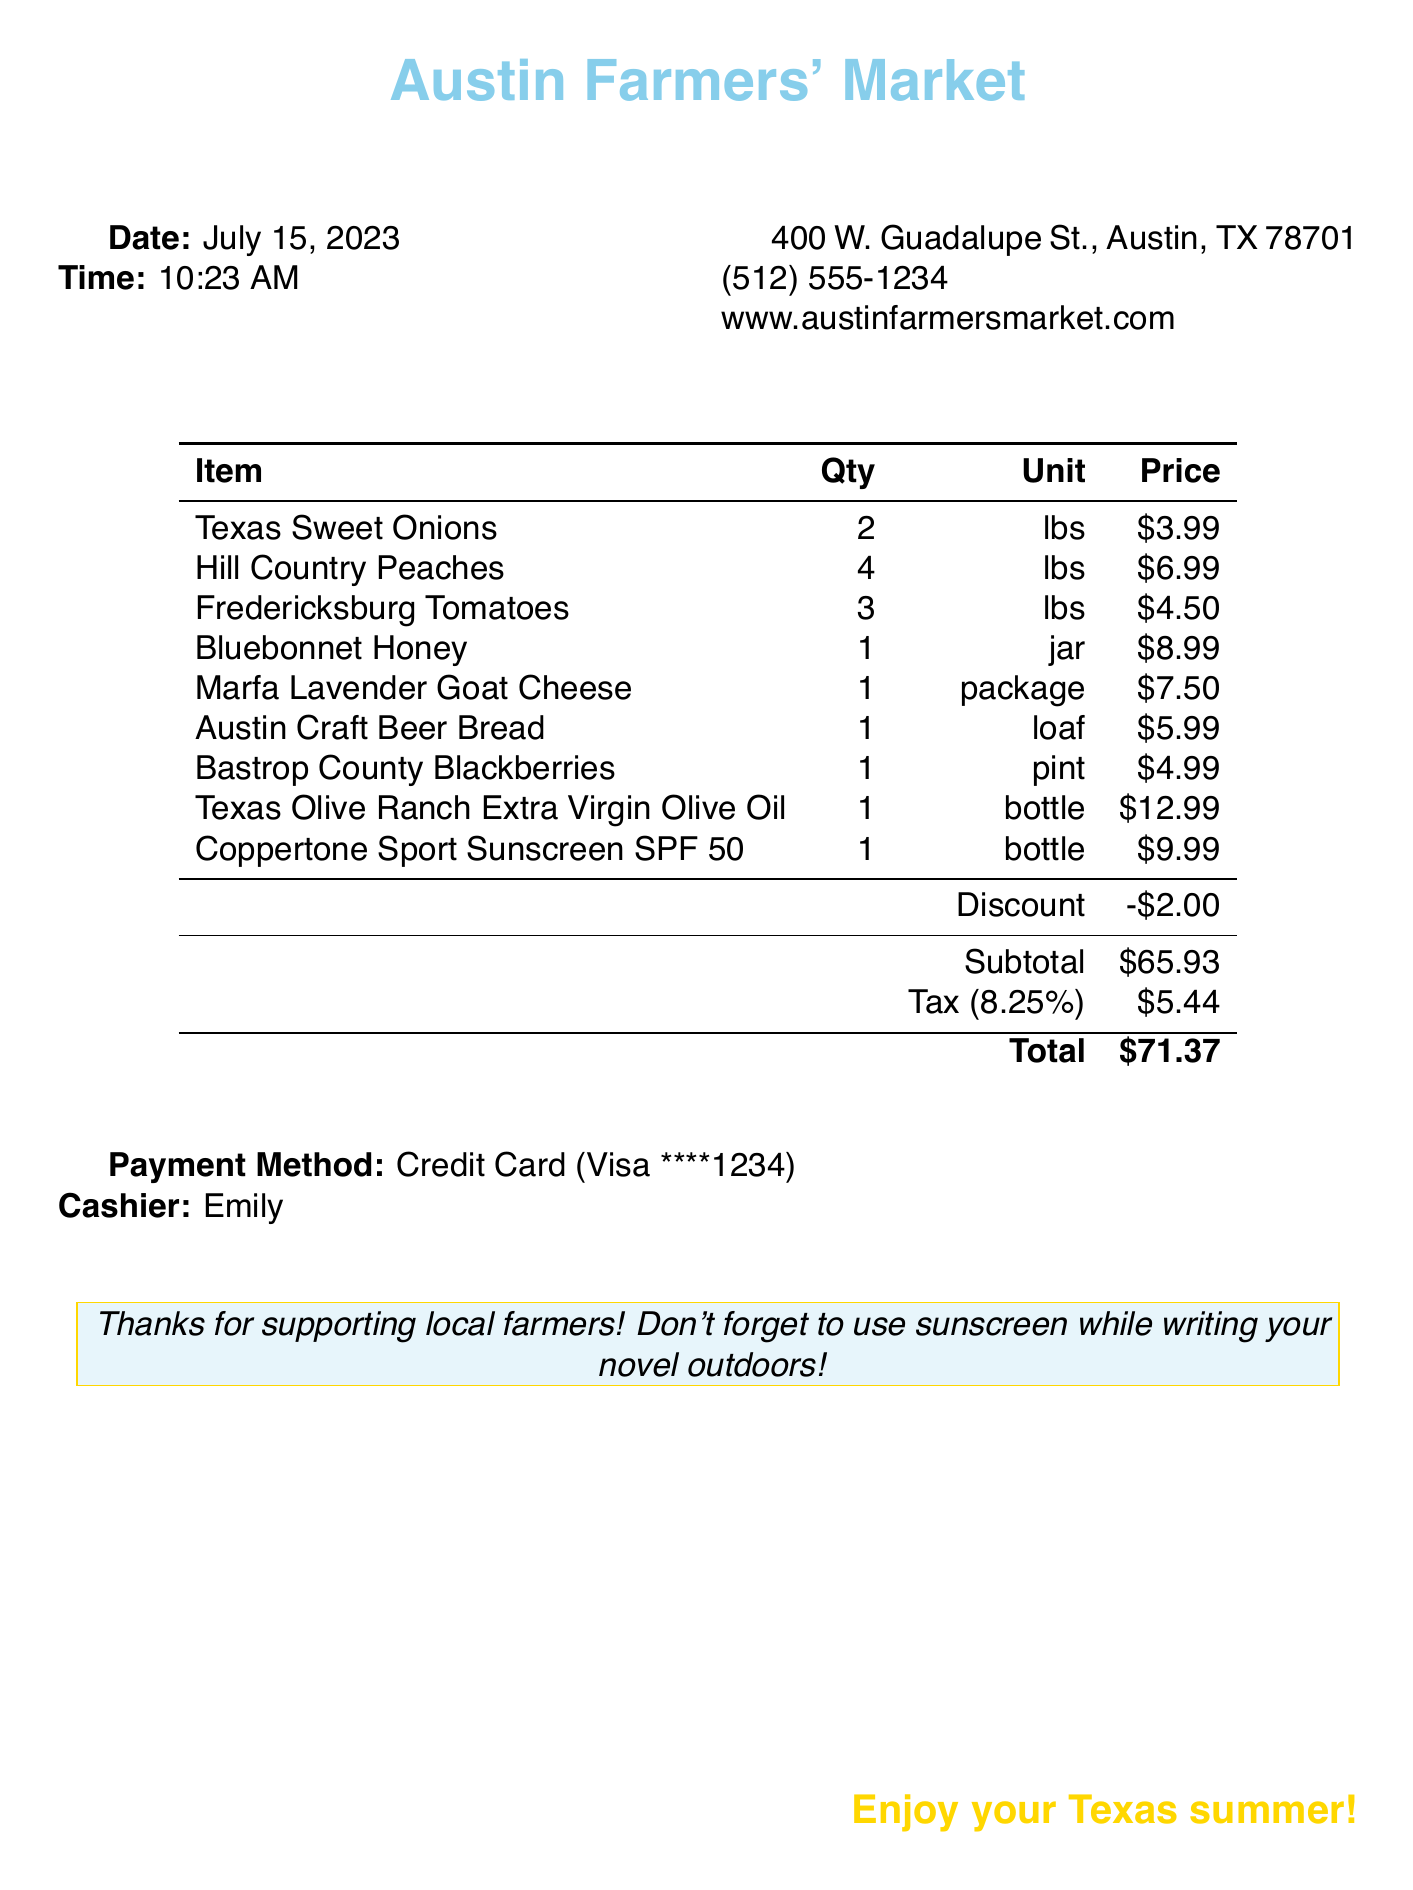What is the store name? The document mentions the store name at the top, which is the "Austin Farmers' Market."
Answer: Austin Farmers' Market What is the date of the purchase? The date is specified clearly in the document as July 15, 2023.
Answer: July 15, 2023 How many pounds of Hill Country Peaches were purchased? The quantity of Hill Country Peaches is listed as 4 lbs in the items section.
Answer: 4 lbs What discount was applied to the sunscreen? The document indicates that a discount of $2.00 was applied to the sunscreen item.
Answer: $2.00 What is the total amount spent? The total is presented at the bottom of the receipt as $71.37.
Answer: $71.37 Who was the cashier for this transaction? The cashier's name is noted as Emily in the section for payment details.
Answer: Emily How much tax was applied to the subtotal? The tax rate of 8.25% is applied, and the tax amount specified is $5.44.
Answer: $5.44 What type of payment was used? The payment method is clearly stated as "Credit Card" and specifically mentions Visa.
Answer: Credit Card (Visa) What is one item included in the purchase that is made from Texas produce? There are several items, and Texas Sweet Onions is one of the items listed as fresh produce from Texas.
Answer: Texas Sweet Onions 